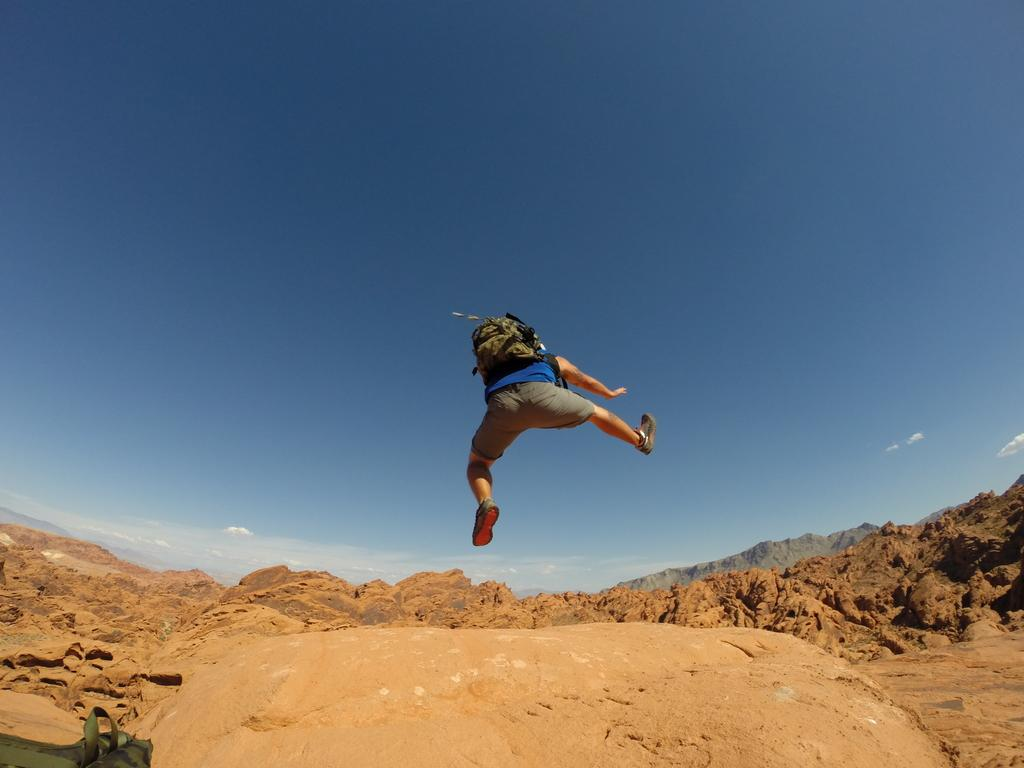Who or what is in the image? There is a person in the image. What is the person doing in the image? The person is in the air. What is the person wearing? The person is wearing a blue shirt and gray shorts. What is the person carrying? The person is carrying a bag. What can be seen in the background of the image? There are mountains visible in the background of the image. What is the color of the sky in the image? The sky is blue and white in color. How many dimes can be seen floating in the river in the image? There is no river or dimes present in the image. What type of army is visible in the image? There is no army present in the image. 